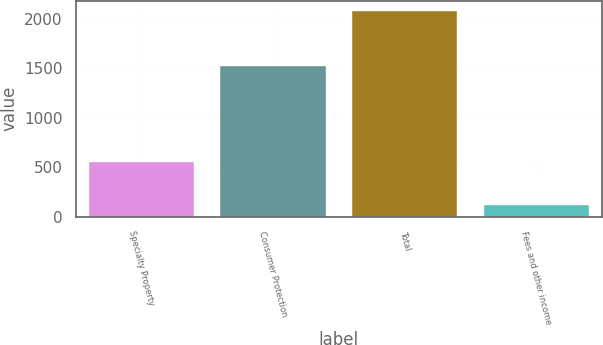Convert chart. <chart><loc_0><loc_0><loc_500><loc_500><bar_chart><fcel>Specialty Property<fcel>Consumer Protection<fcel>Total<fcel>Fees and other income<nl><fcel>552<fcel>1525<fcel>2077<fcel>119<nl></chart> 